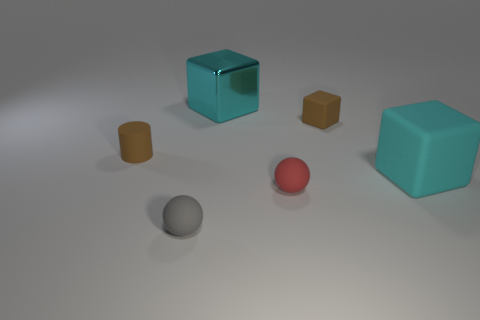Is there any other thing that is the same size as the cyan matte object?
Your answer should be compact. Yes. What shape is the thing that is the same color as the small block?
Your response must be concise. Cylinder. What number of other things are the same shape as the gray rubber thing?
Provide a succinct answer. 1. What number of rubber things are large yellow cylinders or big blocks?
Provide a short and direct response. 1. What material is the small brown object that is behind the brown matte cylinder that is to the left of the small red sphere?
Ensure brevity in your answer.  Rubber. Is the number of small matte things that are behind the gray object greater than the number of big gray rubber cylinders?
Make the answer very short. Yes. Are there any gray spheres made of the same material as the gray object?
Your answer should be compact. No. There is a brown thing on the right side of the tiny gray matte ball; is it the same shape as the large metallic thing?
Your answer should be compact. Yes. How many large rubber things are behind the small brown rubber thing that is to the right of the tiny red matte sphere on the left side of the brown cube?
Provide a short and direct response. 0. Is the number of spheres behind the red matte ball less than the number of small cubes right of the metallic block?
Make the answer very short. Yes. 